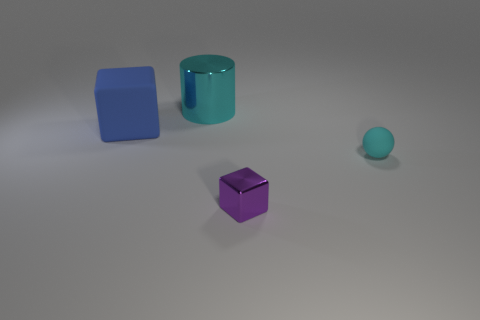How does the lighting affect the appearance of the objects in the scene? The lighting in the scene is soft and diffused, producing subtle shadows and giving the objects a slightly matte look. This kind of lighting reduces harsh reflections and allows for the colors and textures of the objects to be more apparent, suggesting a calm and balanced atmosphere. 